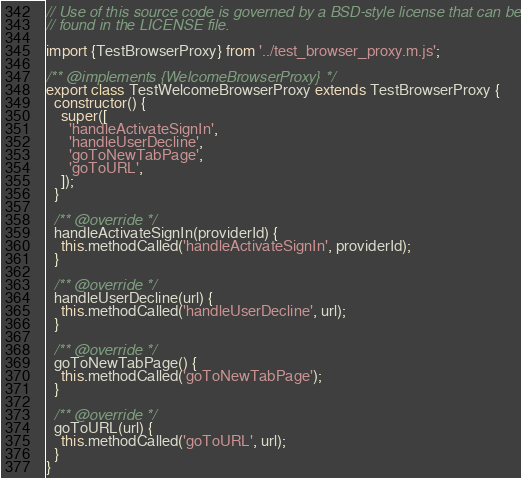Convert code to text. <code><loc_0><loc_0><loc_500><loc_500><_JavaScript_>// Use of this source code is governed by a BSD-style license that can be
// found in the LICENSE file.

import {TestBrowserProxy} from '../test_browser_proxy.m.js';

/** @implements {WelcomeBrowserProxy} */
export class TestWelcomeBrowserProxy extends TestBrowserProxy {
  constructor() {
    super([
      'handleActivateSignIn',
      'handleUserDecline',
      'goToNewTabPage',
      'goToURL',
    ]);
  }

  /** @override */
  handleActivateSignIn(providerId) {
    this.methodCalled('handleActivateSignIn', providerId);
  }

  /** @override */
  handleUserDecline(url) {
    this.methodCalled('handleUserDecline', url);
  }

  /** @override */
  goToNewTabPage() {
    this.methodCalled('goToNewTabPage');
  }

  /** @override */
  goToURL(url) {
    this.methodCalled('goToURL', url);
  }
}
</code> 